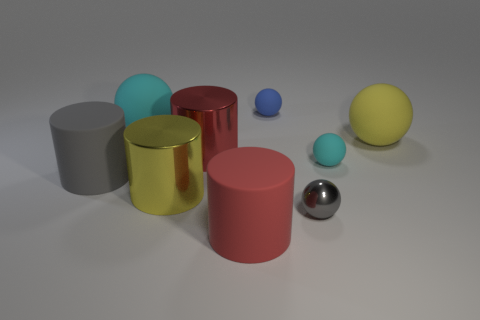Subtract all yellow matte spheres. How many spheres are left? 4 Subtract all gray cylinders. How many cyan spheres are left? 2 Subtract all yellow cylinders. How many cylinders are left? 3 Subtract 1 cyan balls. How many objects are left? 8 Subtract all cylinders. How many objects are left? 5 Subtract 2 balls. How many balls are left? 3 Subtract all gray cylinders. Subtract all brown balls. How many cylinders are left? 3 Subtract all yellow spheres. Subtract all rubber objects. How many objects are left? 2 Add 6 yellow cylinders. How many yellow cylinders are left? 7 Add 9 large cyan spheres. How many large cyan spheres exist? 10 